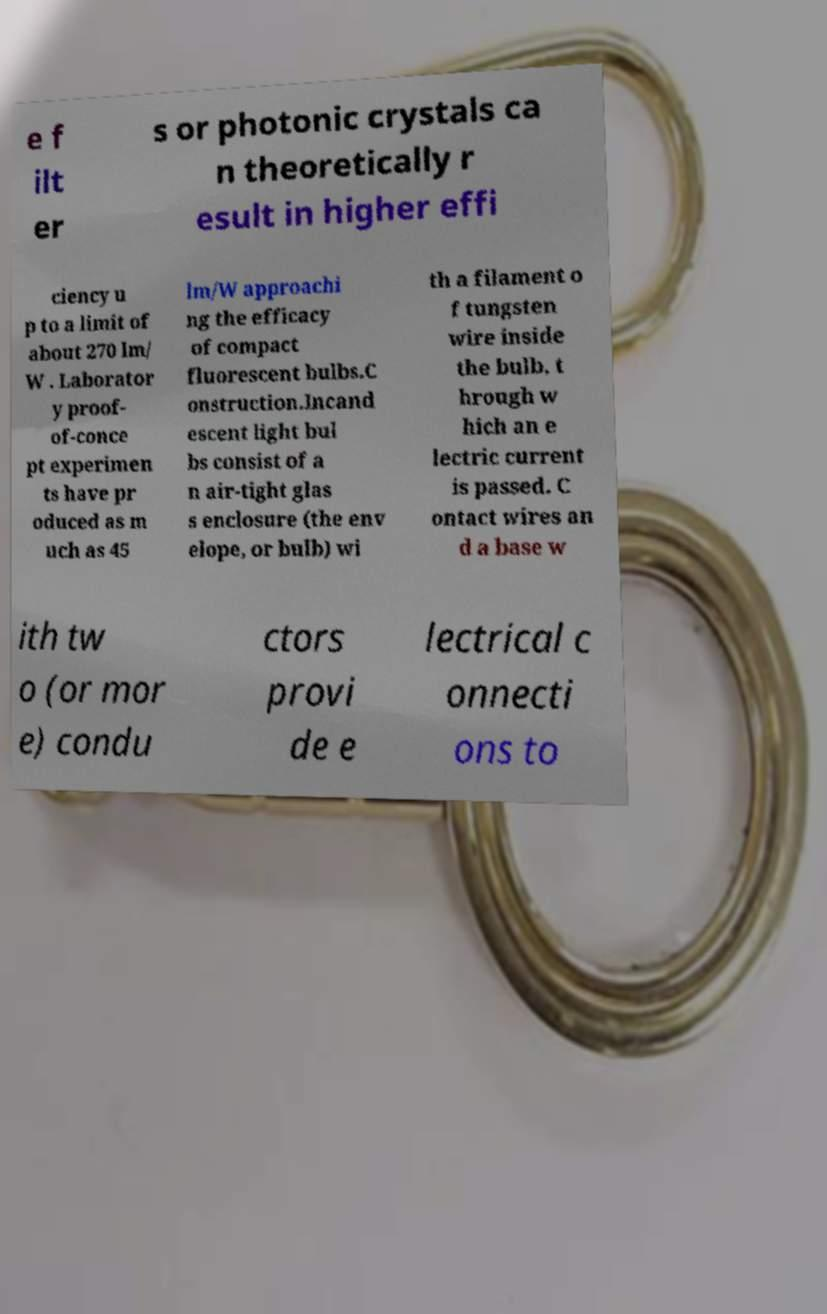Can you accurately transcribe the text from the provided image for me? e f ilt er s or photonic crystals ca n theoretically r esult in higher effi ciency u p to a limit of about 270 lm/ W . Laborator y proof- of-conce pt experimen ts have pr oduced as m uch as 45 lm/W approachi ng the efficacy of compact fluorescent bulbs.C onstruction.Incand escent light bul bs consist of a n air-tight glas s enclosure (the env elope, or bulb) wi th a filament o f tungsten wire inside the bulb, t hrough w hich an e lectric current is passed. C ontact wires an d a base w ith tw o (or mor e) condu ctors provi de e lectrical c onnecti ons to 